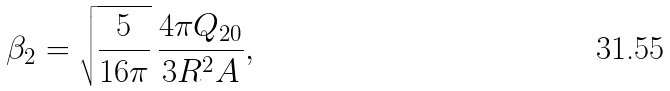<formula> <loc_0><loc_0><loc_500><loc_500>\beta _ { 2 } = \sqrt { \frac { 5 } { 1 6 \pi } } \, \frac { 4 \pi Q _ { 2 0 } } { 3 R ^ { 2 } A } ,</formula> 